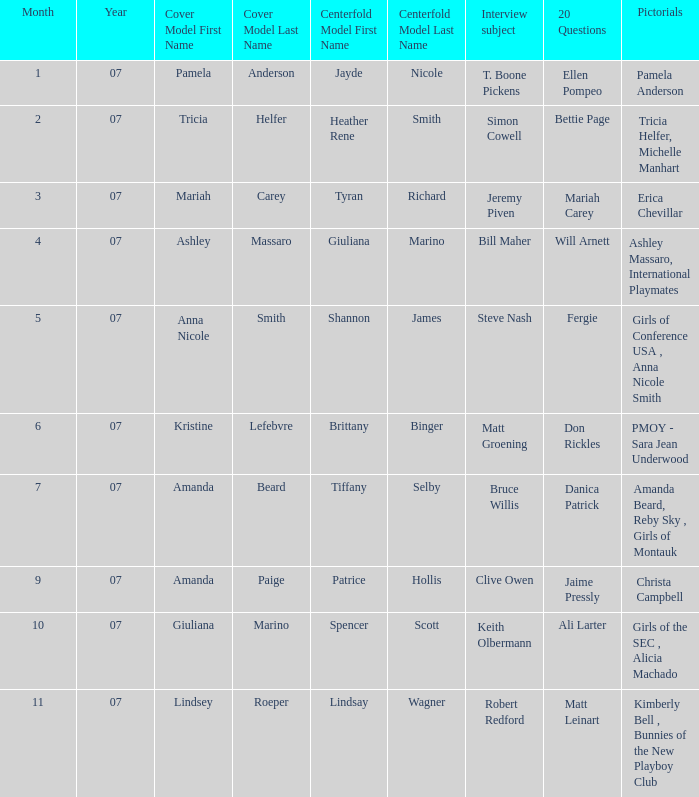List the pictorals from issues when lindsey roeper was the cover model. Kimberly Bell , Bunnies of the New Playboy Club. 